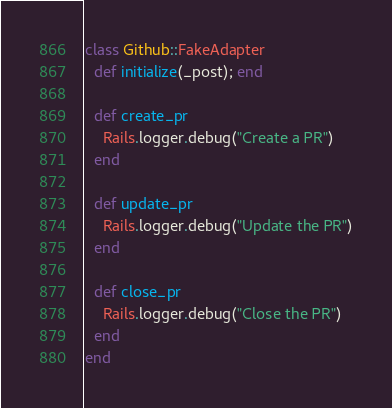<code> <loc_0><loc_0><loc_500><loc_500><_Ruby_>class Github::FakeAdapter
  def initialize(_post); end

  def create_pr
    Rails.logger.debug("Create a PR")
  end

  def update_pr
    Rails.logger.debug("Update the PR")
  end

  def close_pr
    Rails.logger.debug("Close the PR")
  end
end
</code> 